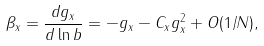<formula> <loc_0><loc_0><loc_500><loc_500>\beta _ { x } = \frac { d g _ { x } } { d \ln b } = - g _ { x } - C _ { x } g _ { x } ^ { 2 } + O ( 1 / N ) ,</formula> 